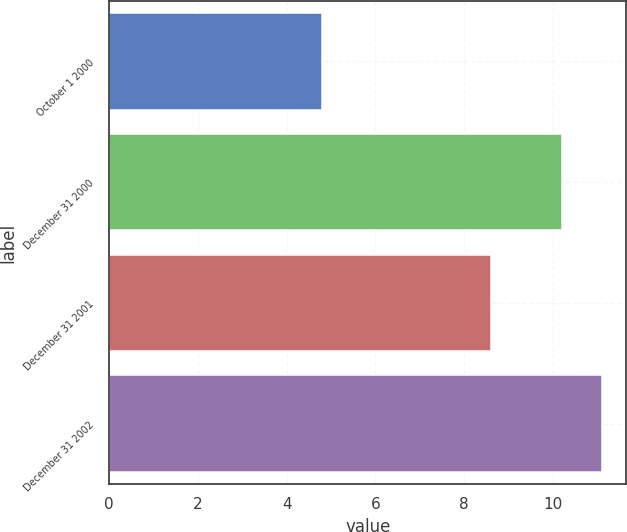Convert chart to OTSL. <chart><loc_0><loc_0><loc_500><loc_500><bar_chart><fcel>October 1 2000<fcel>December 31 2000<fcel>December 31 2001<fcel>December 31 2002<nl><fcel>4.8<fcel>10.2<fcel>8.6<fcel>11.1<nl></chart> 